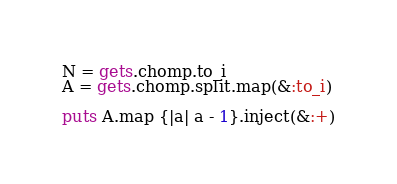Convert code to text. <code><loc_0><loc_0><loc_500><loc_500><_Ruby_>N = gets.chomp.to_i
A = gets.chomp.split.map(&:to_i)

puts A.map {|a| a - 1}.inject(&:+)</code> 